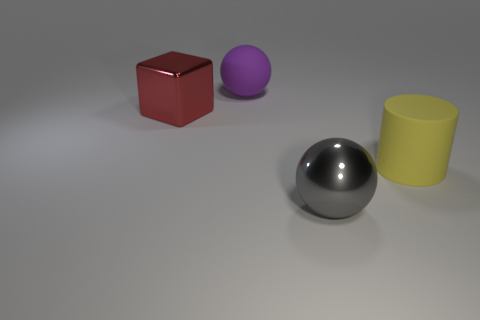There is a object that is behind the red cube; is its shape the same as the yellow rubber thing?
Give a very brief answer. No. Are there fewer metal spheres behind the metal sphere than big red shiny objects that are in front of the large yellow matte object?
Make the answer very short. No. What is the material of the sphere that is to the right of the big matte ball?
Your answer should be very brief. Metal. Are there any gray spheres that have the same size as the cube?
Your answer should be very brief. Yes. There is a large purple thing; is it the same shape as the large object in front of the yellow object?
Make the answer very short. Yes. There is a rubber object that is in front of the large rubber sphere; is its size the same as the matte object that is behind the yellow cylinder?
Ensure brevity in your answer.  Yes. What number of other things are there of the same shape as the yellow thing?
Provide a short and direct response. 0. What material is the block that is on the left side of the large gray metal thing to the right of the purple matte ball?
Keep it short and to the point. Metal. How many metallic objects are either big purple things or gray things?
Make the answer very short. 1. Is there anything else that is the same material as the red thing?
Offer a terse response. Yes. 